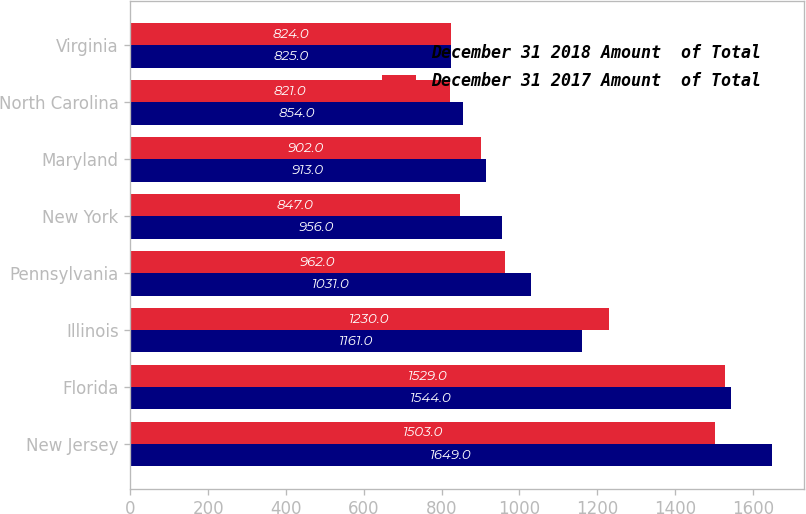Convert chart to OTSL. <chart><loc_0><loc_0><loc_500><loc_500><stacked_bar_chart><ecel><fcel>New Jersey<fcel>Florida<fcel>Illinois<fcel>Pennsylvania<fcel>New York<fcel>Maryland<fcel>North Carolina<fcel>Virginia<nl><fcel>December 31 2018 Amount  of Total<fcel>1649<fcel>1544<fcel>1161<fcel>1031<fcel>956<fcel>913<fcel>854<fcel>825<nl><fcel>December 31 2017 Amount  of Total<fcel>1503<fcel>1529<fcel>1230<fcel>962<fcel>847<fcel>902<fcel>821<fcel>824<nl></chart> 